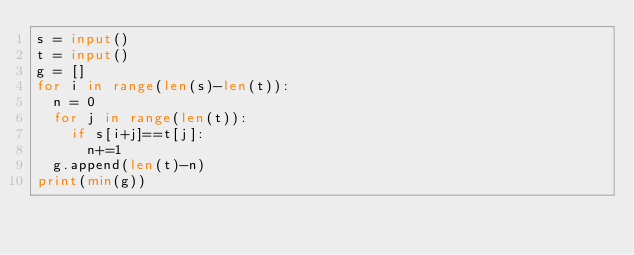Convert code to text. <code><loc_0><loc_0><loc_500><loc_500><_Python_>s = input()
t = input()
g = []
for i in range(len(s)-len(t)):
  n = 0
  for j in range(len(t)):
    if s[i+j]==t[j]:
      n+=1
  g.append(len(t)-n)
print(min(g))</code> 